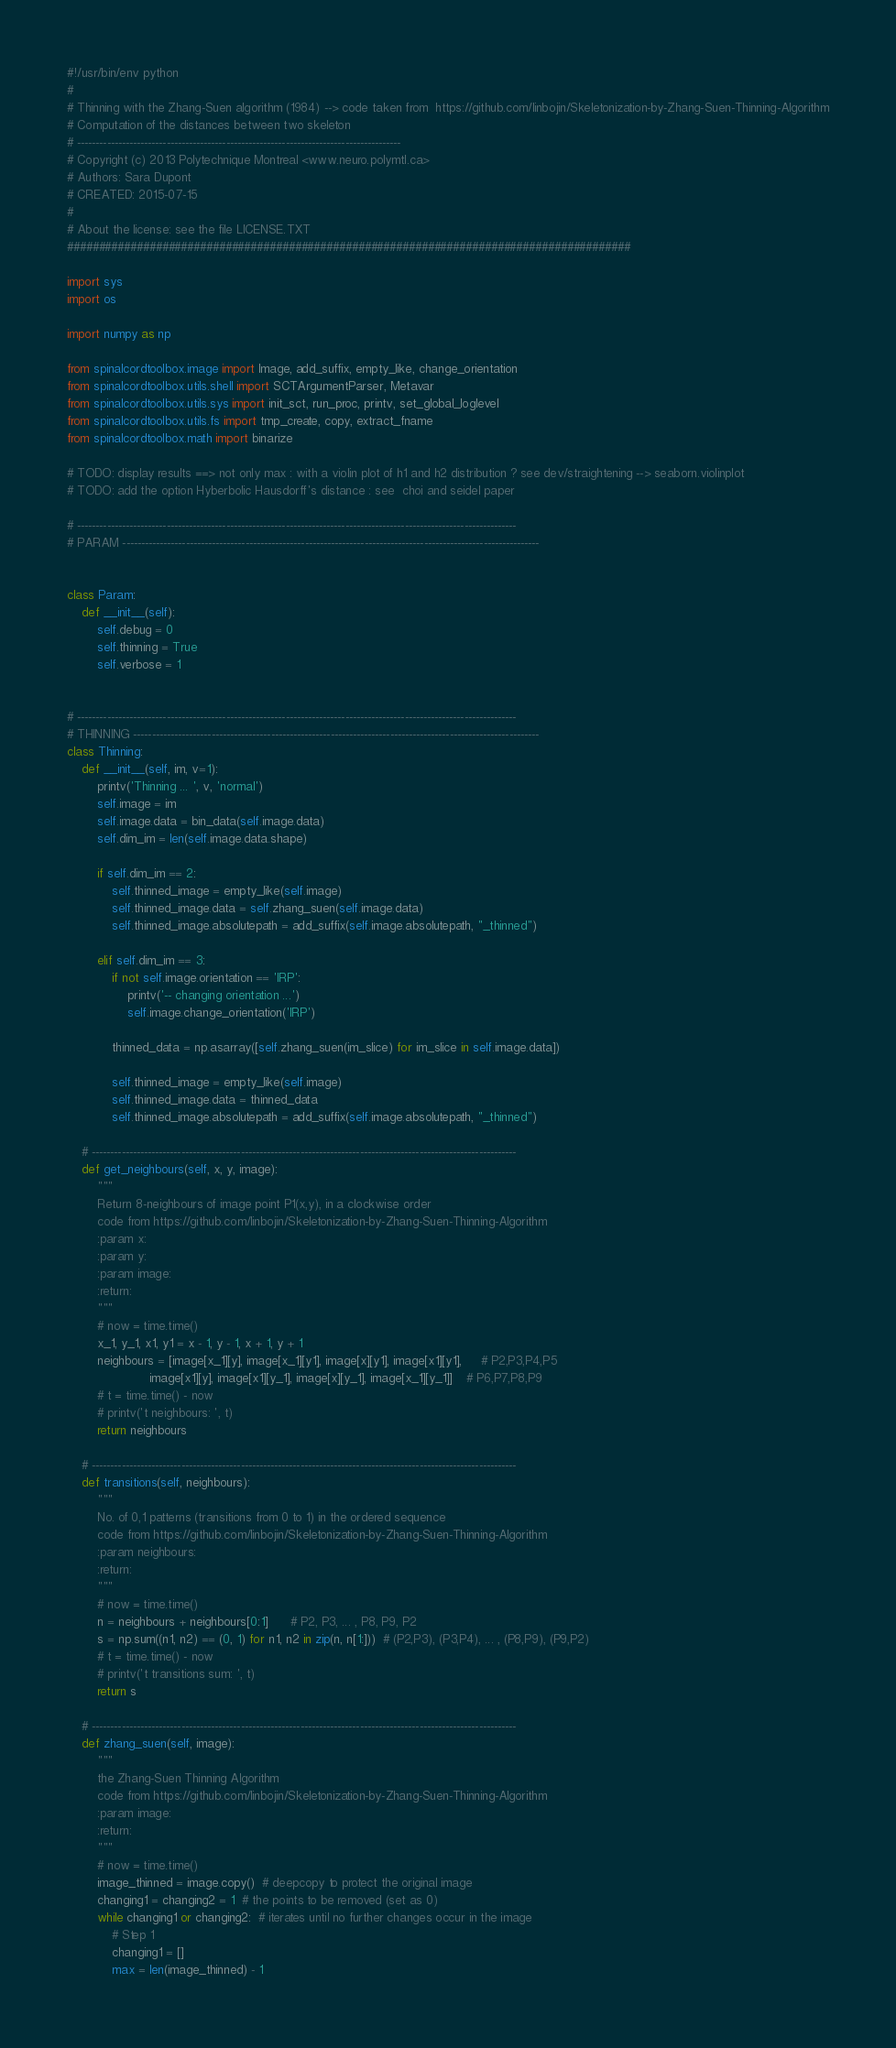Convert code to text. <code><loc_0><loc_0><loc_500><loc_500><_Python_>#!/usr/bin/env python
#
# Thinning with the Zhang-Suen algorithm (1984) --> code taken from  https://github.com/linbojin/Skeletonization-by-Zhang-Suen-Thinning-Algorithm
# Computation of the distances between two skeleton
# ---------------------------------------------------------------------------------------
# Copyright (c) 2013 Polytechnique Montreal <www.neuro.polymtl.ca>
# Authors: Sara Dupont
# CREATED: 2015-07-15
#
# About the license: see the file LICENSE.TXT
#########################################################################################

import sys
import os

import numpy as np

from spinalcordtoolbox.image import Image, add_suffix, empty_like, change_orientation
from spinalcordtoolbox.utils.shell import SCTArgumentParser, Metavar
from spinalcordtoolbox.utils.sys import init_sct, run_proc, printv, set_global_loglevel
from spinalcordtoolbox.utils.fs import tmp_create, copy, extract_fname
from spinalcordtoolbox.math import binarize

# TODO: display results ==> not only max : with a violin plot of h1 and h2 distribution ? see dev/straightening --> seaborn.violinplot
# TODO: add the option Hyberbolic Hausdorff's distance : see  choi and seidel paper

# ----------------------------------------------------------------------------------------------------------------------
# PARAM ----------------------------------------------------------------------------------------------------------------


class Param:
    def __init__(self):
        self.debug = 0
        self.thinning = True
        self.verbose = 1


# ----------------------------------------------------------------------------------------------------------------------
# THINNING -------------------------------------------------------------------------------------------------------------
class Thinning:
    def __init__(self, im, v=1):
        printv('Thinning ... ', v, 'normal')
        self.image = im
        self.image.data = bin_data(self.image.data)
        self.dim_im = len(self.image.data.shape)

        if self.dim_im == 2:
            self.thinned_image = empty_like(self.image)
            self.thinned_image.data = self.zhang_suen(self.image.data)
            self.thinned_image.absolutepath = add_suffix(self.image.absolutepath, "_thinned")

        elif self.dim_im == 3:
            if not self.image.orientation == 'IRP':
                printv('-- changing orientation ...')
                self.image.change_orientation('IRP')

            thinned_data = np.asarray([self.zhang_suen(im_slice) for im_slice in self.image.data])

            self.thinned_image = empty_like(self.image)
            self.thinned_image.data = thinned_data
            self.thinned_image.absolutepath = add_suffix(self.image.absolutepath, "_thinned")

    # ------------------------------------------------------------------------------------------------------------------
    def get_neighbours(self, x, y, image):
        """
        Return 8-neighbours of image point P1(x,y), in a clockwise order
        code from https://github.com/linbojin/Skeletonization-by-Zhang-Suen-Thinning-Algorithm
        :param x:
        :param y:
        :param image:
        :return:
        """
        # now = time.time()
        x_1, y_1, x1, y1 = x - 1, y - 1, x + 1, y + 1
        neighbours = [image[x_1][y], image[x_1][y1], image[x][y1], image[x1][y1],     # P2,P3,P4,P5
                      image[x1][y], image[x1][y_1], image[x][y_1], image[x_1][y_1]]    # P6,P7,P8,P9
        # t = time.time() - now
        # printv('t neighbours: ', t)
        return neighbours

    # ------------------------------------------------------------------------------------------------------------------
    def transitions(self, neighbours):
        """
        No. of 0,1 patterns (transitions from 0 to 1) in the ordered sequence
        code from https://github.com/linbojin/Skeletonization-by-Zhang-Suen-Thinning-Algorithm
        :param neighbours:
        :return:
        """
        # now = time.time()
        n = neighbours + neighbours[0:1]      # P2, P3, ... , P8, P9, P2
        s = np.sum((n1, n2) == (0, 1) for n1, n2 in zip(n, n[1:]))  # (P2,P3), (P3,P4), ... , (P8,P9), (P9,P2)
        # t = time.time() - now
        # printv('t transitions sum: ', t)
        return s

    # ------------------------------------------------------------------------------------------------------------------
    def zhang_suen(self, image):
        """
        the Zhang-Suen Thinning Algorithm
        code from https://github.com/linbojin/Skeletonization-by-Zhang-Suen-Thinning-Algorithm
        :param image:
        :return:
        """
        # now = time.time()
        image_thinned = image.copy()  # deepcopy to protect the original image
        changing1 = changing2 = 1  # the points to be removed (set as 0)
        while changing1 or changing2:  # iterates until no further changes occur in the image
            # Step 1
            changing1 = []
            max = len(image_thinned) - 1</code> 